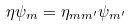Convert formula to latex. <formula><loc_0><loc_0><loc_500><loc_500>\eta \psi _ { m } = \eta _ { m m ^ { \prime } } \psi _ { m ^ { \prime } }</formula> 